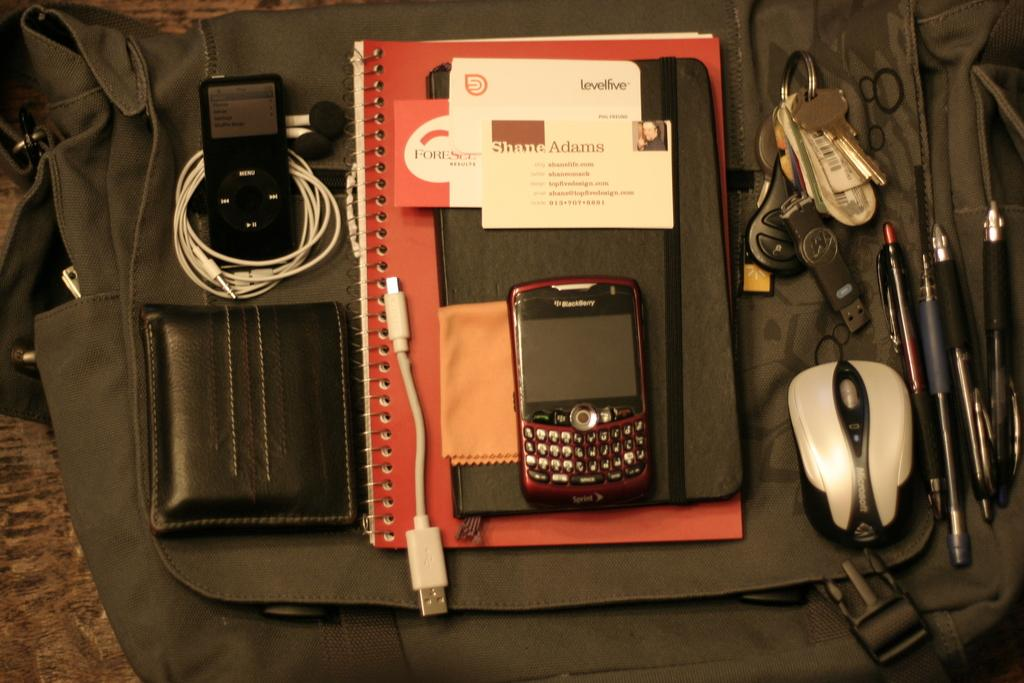What type of furniture is present in the image? There is a table in the image. What is placed on the table? There is a bag on the table. What items are on the bag? There is a book, a mobile, a wallet, airpods, keys, a mouse, and pens on the bag. What type of payment method is being used in the image? There is no payment method being used in the image; it only shows a bag with various items on it. 